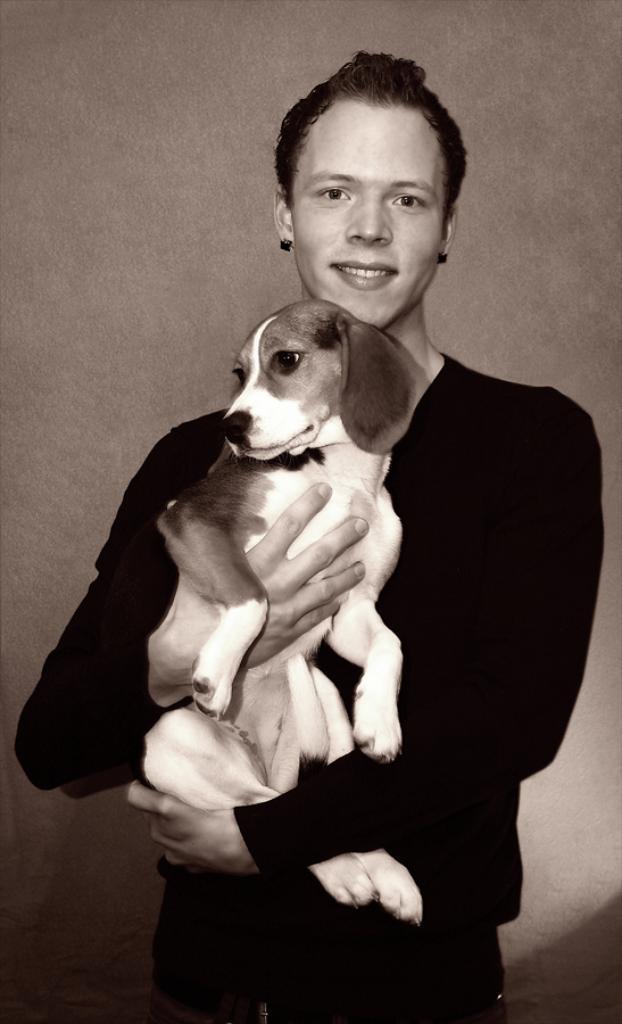Could you give a brief overview of what you see in this image? In this image we can see a man standing in the center. He is holding a dog in his hand and he is smiling. 